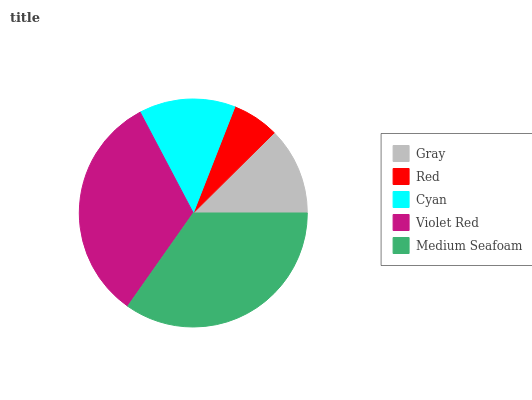Is Red the minimum?
Answer yes or no. Yes. Is Medium Seafoam the maximum?
Answer yes or no. Yes. Is Cyan the minimum?
Answer yes or no. No. Is Cyan the maximum?
Answer yes or no. No. Is Cyan greater than Red?
Answer yes or no. Yes. Is Red less than Cyan?
Answer yes or no. Yes. Is Red greater than Cyan?
Answer yes or no. No. Is Cyan less than Red?
Answer yes or no. No. Is Cyan the high median?
Answer yes or no. Yes. Is Cyan the low median?
Answer yes or no. Yes. Is Red the high median?
Answer yes or no. No. Is Violet Red the low median?
Answer yes or no. No. 